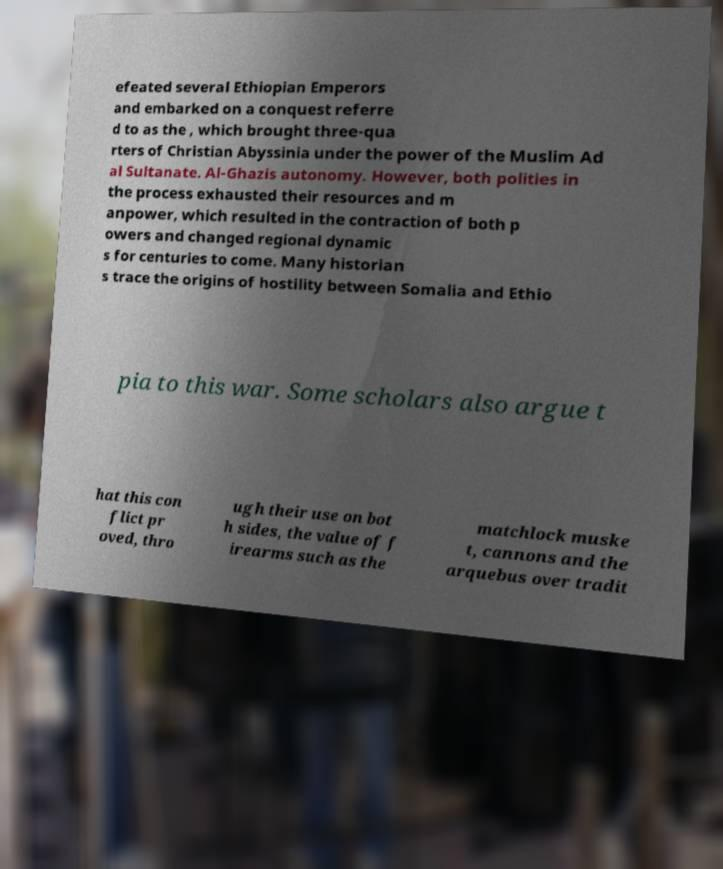What messages or text are displayed in this image? I need them in a readable, typed format. efeated several Ethiopian Emperors and embarked on a conquest referre d to as the , which brought three-qua rters of Christian Abyssinia under the power of the Muslim Ad al Sultanate. Al-Ghazis autonomy. However, both polities in the process exhausted their resources and m anpower, which resulted in the contraction of both p owers and changed regional dynamic s for centuries to come. Many historian s trace the origins of hostility between Somalia and Ethio pia to this war. Some scholars also argue t hat this con flict pr oved, thro ugh their use on bot h sides, the value of f irearms such as the matchlock muske t, cannons and the arquebus over tradit 